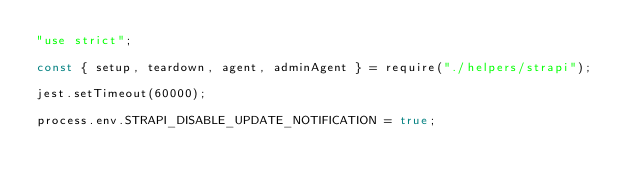Convert code to text. <code><loc_0><loc_0><loc_500><loc_500><_JavaScript_>"use strict";

const { setup, teardown, agent, adminAgent } = require("./helpers/strapi");

jest.setTimeout(60000);

process.env.STRAPI_DISABLE_UPDATE_NOTIFICATION = true;</code> 